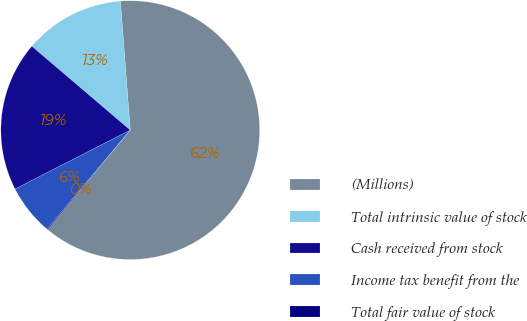<chart> <loc_0><loc_0><loc_500><loc_500><pie_chart><fcel>(Millions)<fcel>Total intrinsic value of stock<fcel>Cash received from stock<fcel>Income tax benefit from the<fcel>Total fair value of stock<nl><fcel>62.24%<fcel>12.55%<fcel>18.76%<fcel>6.34%<fcel>0.12%<nl></chart> 